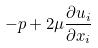Convert formula to latex. <formula><loc_0><loc_0><loc_500><loc_500>- p + 2 \mu \frac { \partial u _ { i } } { \partial x _ { i } }</formula> 